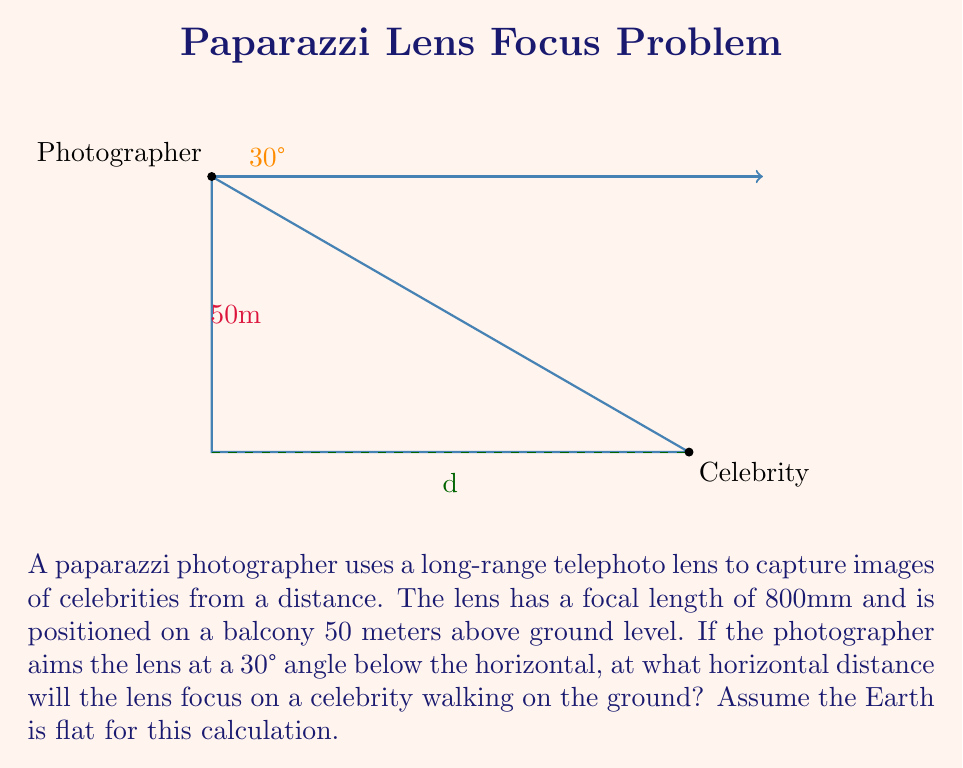Show me your answer to this math problem. Let's approach this step-by-step:

1) First, we need to understand that this problem involves a right-angled triangle. The photographer's position is at the top angle, and we need to find the horizontal distance to the celebrity.

2) We know:
   - The height of the photographer: 50 meters
   - The angle of depression: 30°

3) In a right-angled triangle, we can use trigonometric ratios. Here, we need to use the tangent ratio:

   $$\tan \theta = \frac{\text{opposite}}{\text{adjacent}}$$

4) In our case:
   $$\tan 30° = \frac{50}{\text{horizontal distance}}$$

5) We can rearrange this to solve for the horizontal distance:

   $$\text{horizontal distance} = \frac{50}{\tan 30°}$$

6) Now, let's calculate:
   $$\tan 30° = \frac{1}{\sqrt{3}} \approx 0.5774$$

   $$\text{horizontal distance} = \frac{50}{0.5774} \approx 86.60 \text{ meters}$$

7) Note that the focal length of the lens (800mm) doesn't affect this calculation. It determines the magnification of the image, not the distance at which it focuses.
Answer: 86.60 meters 